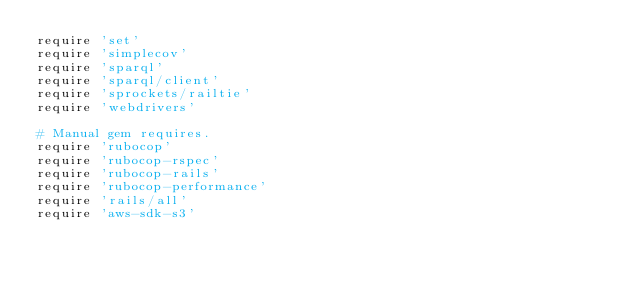<code> <loc_0><loc_0><loc_500><loc_500><_Ruby_>require 'set'
require 'simplecov'
require 'sparql'
require 'sparql/client'
require 'sprockets/railtie'
require 'webdrivers'

# Manual gem requires.
require 'rubocop'
require 'rubocop-rspec'
require 'rubocop-rails'
require 'rubocop-performance'
require 'rails/all'
require 'aws-sdk-s3'
</code> 